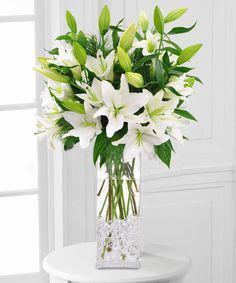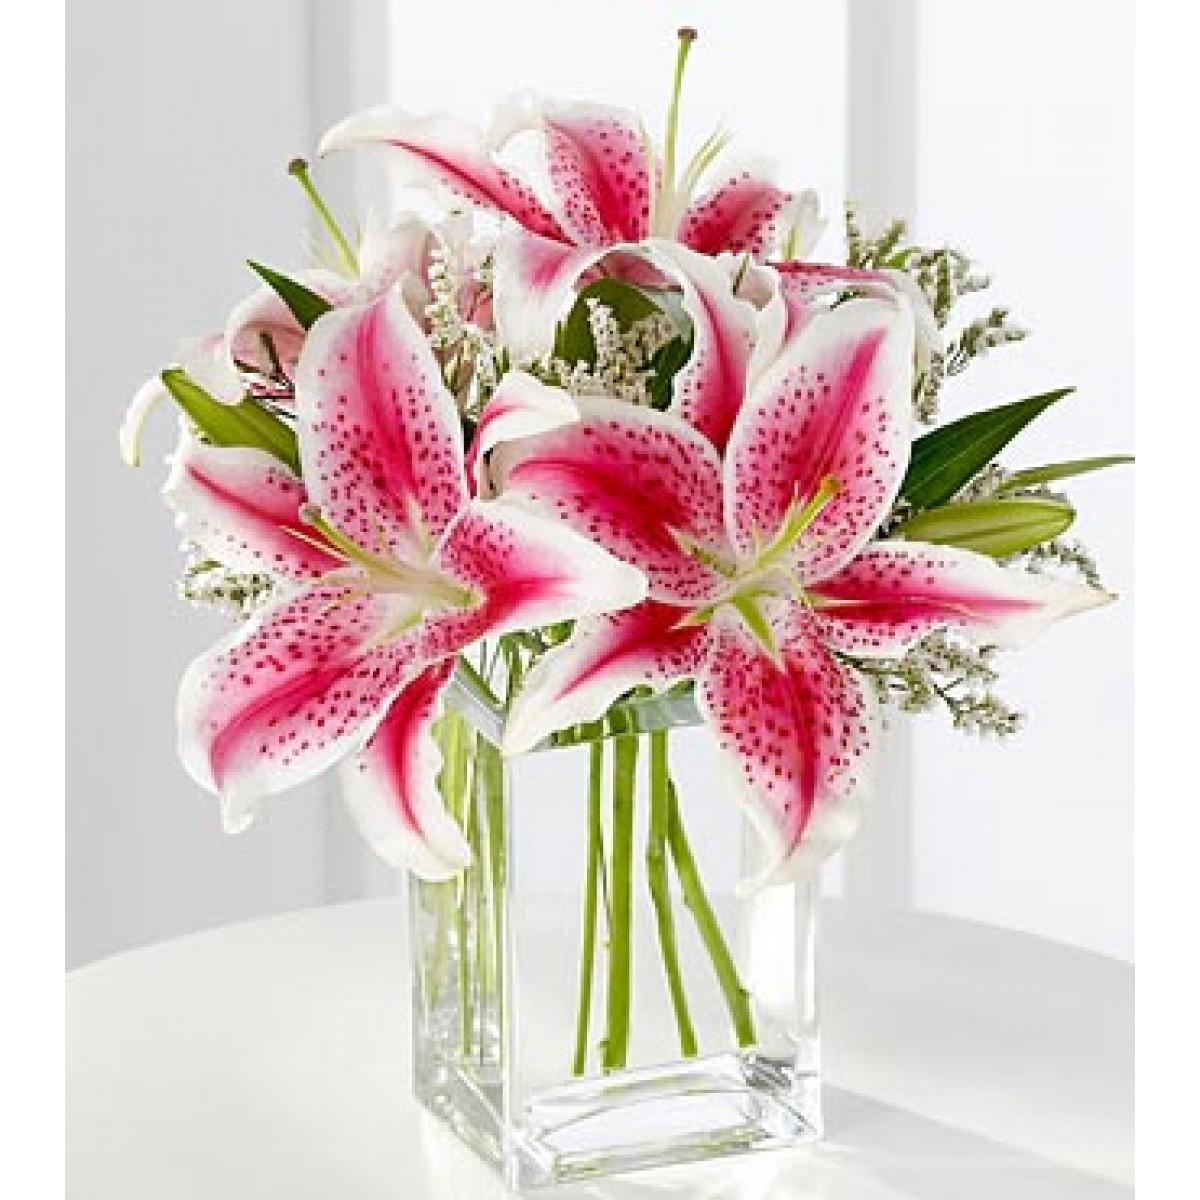The first image is the image on the left, the second image is the image on the right. Analyze the images presented: Is the assertion "One arrangement showcases white flowers and the other contains pink flowers." valid? Answer yes or no. Yes. 